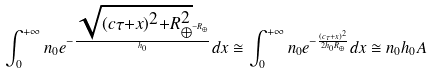Convert formula to latex. <formula><loc_0><loc_0><loc_500><loc_500>\int _ { 0 } ^ { + \infty } n _ { 0 } e ^ { - \frac { \sqrt { ( c \tau + x ) ^ { 2 } + R _ { \oplus } ^ { 2 } } - R _ { \oplus } } { h _ { 0 } } } d x \cong \int _ { 0 } ^ { + \infty } n _ { 0 } e ^ { - \frac { ( c \tau + x ) ^ { 2 } } { 2 h _ { 0 } R _ { \oplus } } } d x \cong n _ { 0 } h _ { 0 } A</formula> 